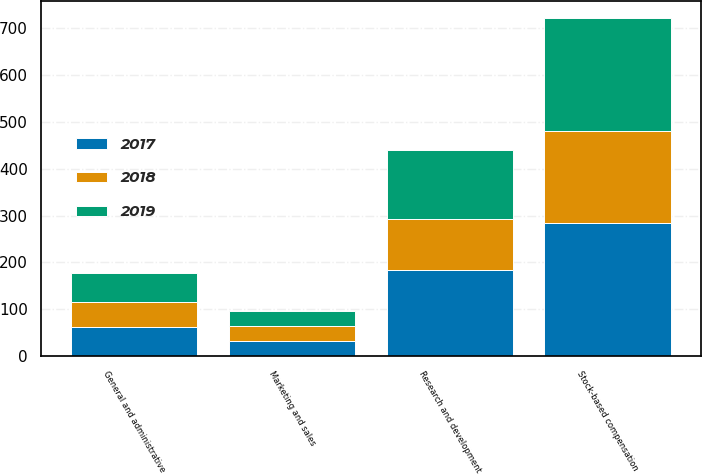Convert chart to OTSL. <chart><loc_0><loc_0><loc_500><loc_500><stacked_bar_chart><ecel><fcel>Research and development<fcel>Marketing and sales<fcel>General and administrative<fcel>Stock-based compensation<nl><fcel>2017<fcel>184<fcel>33<fcel>63<fcel>284<nl><fcel>2019<fcel>146<fcel>32<fcel>61<fcel>242<nl><fcel>2018<fcel>109<fcel>31<fcel>53<fcel>196<nl></chart> 